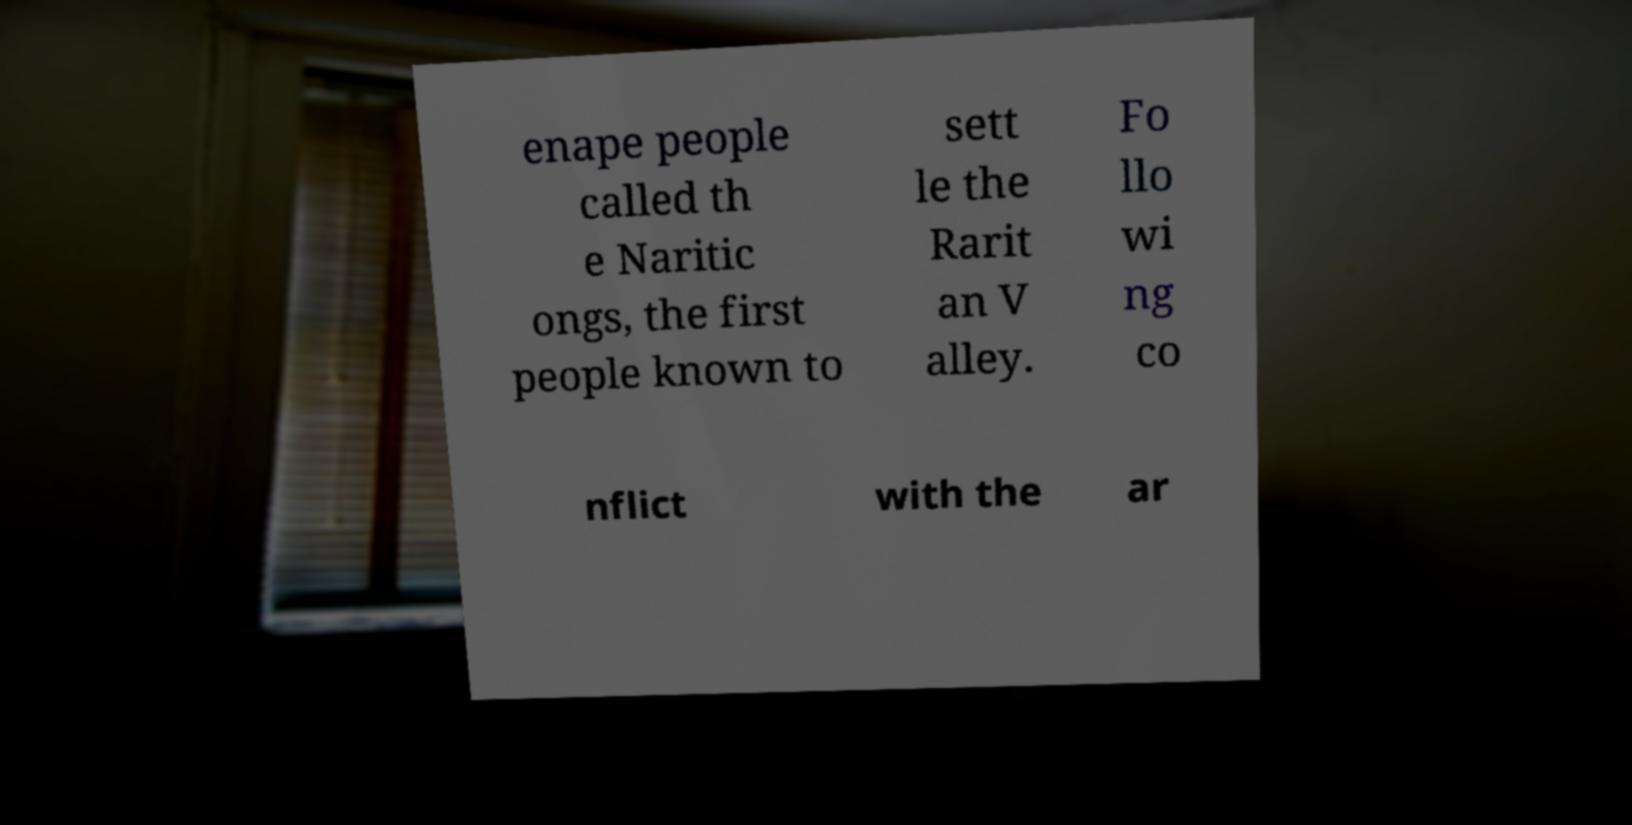Please identify and transcribe the text found in this image. enape people called th e Naritic ongs, the first people known to sett le the Rarit an V alley. Fo llo wi ng co nflict with the ar 